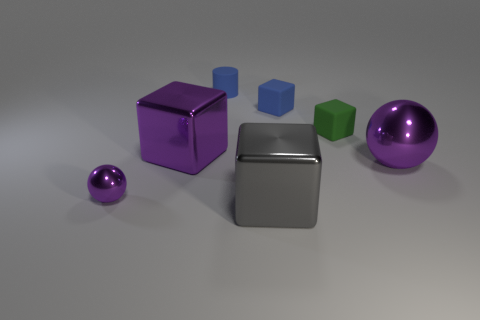Subtract all gray blocks. How many blocks are left? 3 Subtract 1 cubes. How many cubes are left? 3 Add 3 small shiny spheres. How many objects exist? 10 Subtract all green cubes. How many cubes are left? 3 Subtract all red cubes. Subtract all brown cylinders. How many cubes are left? 4 Subtract all cylinders. How many objects are left? 6 Subtract all tiny blue things. Subtract all large blue cylinders. How many objects are left? 5 Add 3 green matte blocks. How many green matte blocks are left? 4 Add 4 tiny purple things. How many tiny purple things exist? 5 Subtract 1 blue cylinders. How many objects are left? 6 